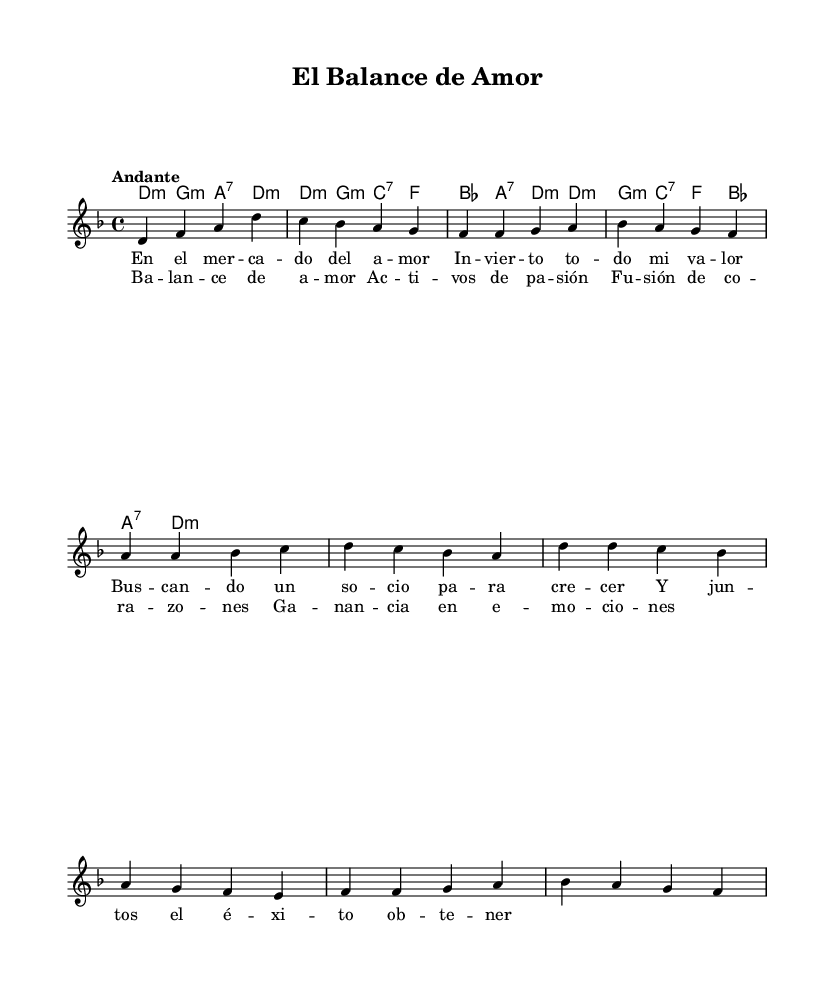What is the key signature of this music? The key signature shown at the beginning of the score indicates two flats, which corresponds to D minor.
Answer: D minor What is the time signature of this music? The time signature is located at the beginning of the score following the key signature. It shows four beats per measure, which corresponds to 4/4 time.
Answer: 4/4 What is the tempo marking for this piece? The tempo marking is provided in the score, and it indicates the desired speed of the music. It is marked as "Andante," meaning a moderately slow tempo.
Answer: Andante How many sections are there in the song? Observing the score, we can identify two main sections indicated by their distinct lyrics: Verse and Chorus. This indicates a standard song structure with verses followed by a chorus.
Answer: Two What type of chords are primarily used in the harmonies? By examining the chords listed in the harmonies section, we see that they are mostly minor chords, followed by dominant seventh chords, typical for this style of bolero music.
Answer: Minor What is the theme of the lyrics in this piece? Analyzing the content of the lyrics, they revolve around the concepts of love, balance, and emotional connection, illustrated through business metaphors which suggest a deeper meaning.
Answer: Love and balance What is the harmonic progression in the chorus? By reviewing the chords accompanying the chorus, we see a repetitive pattern suggesting a sense of resolution, which is characteristic of boleros, often comprised of minor and seventh chords.
Answer: d:m g:m c:7 f 